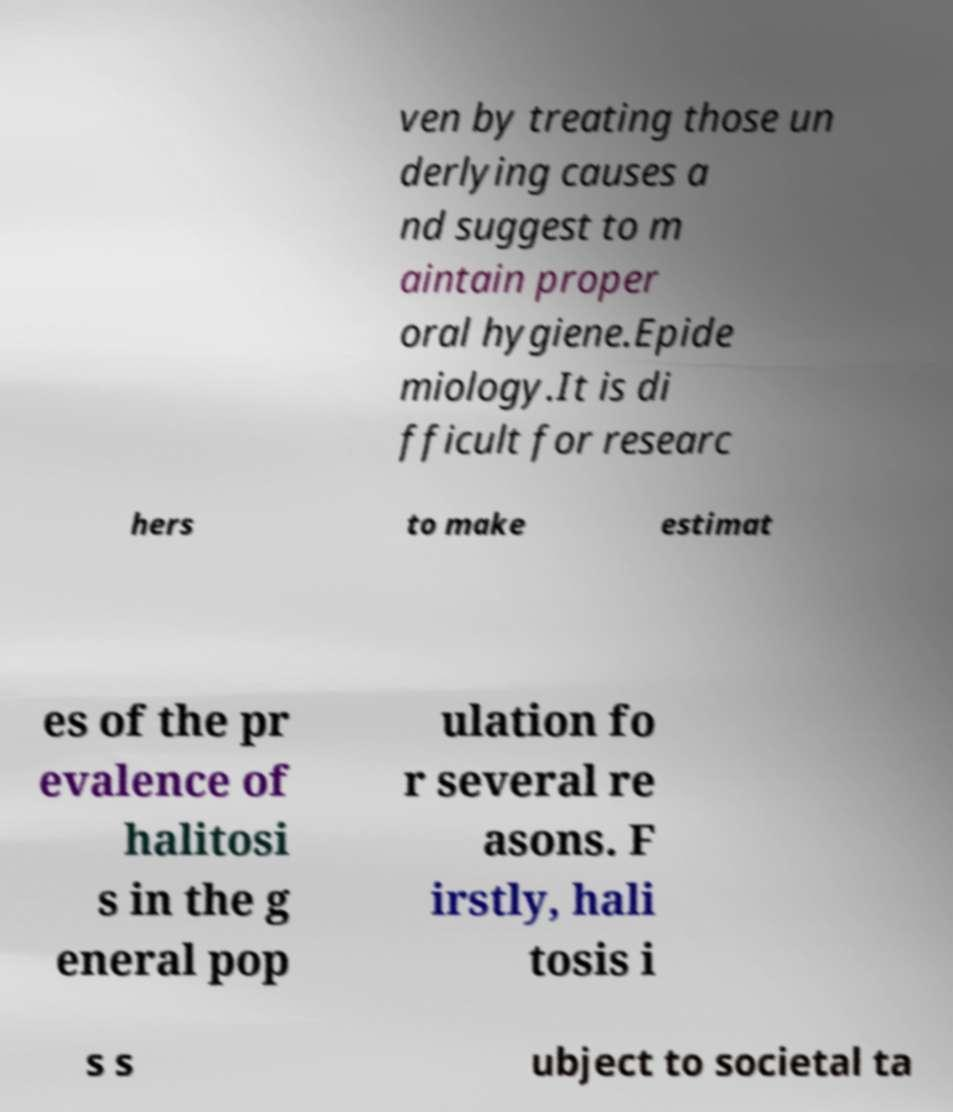There's text embedded in this image that I need extracted. Can you transcribe it verbatim? ven by treating those un derlying causes a nd suggest to m aintain proper oral hygiene.Epide miology.It is di fficult for researc hers to make estimat es of the pr evalence of halitosi s in the g eneral pop ulation fo r several re asons. F irstly, hali tosis i s s ubject to societal ta 